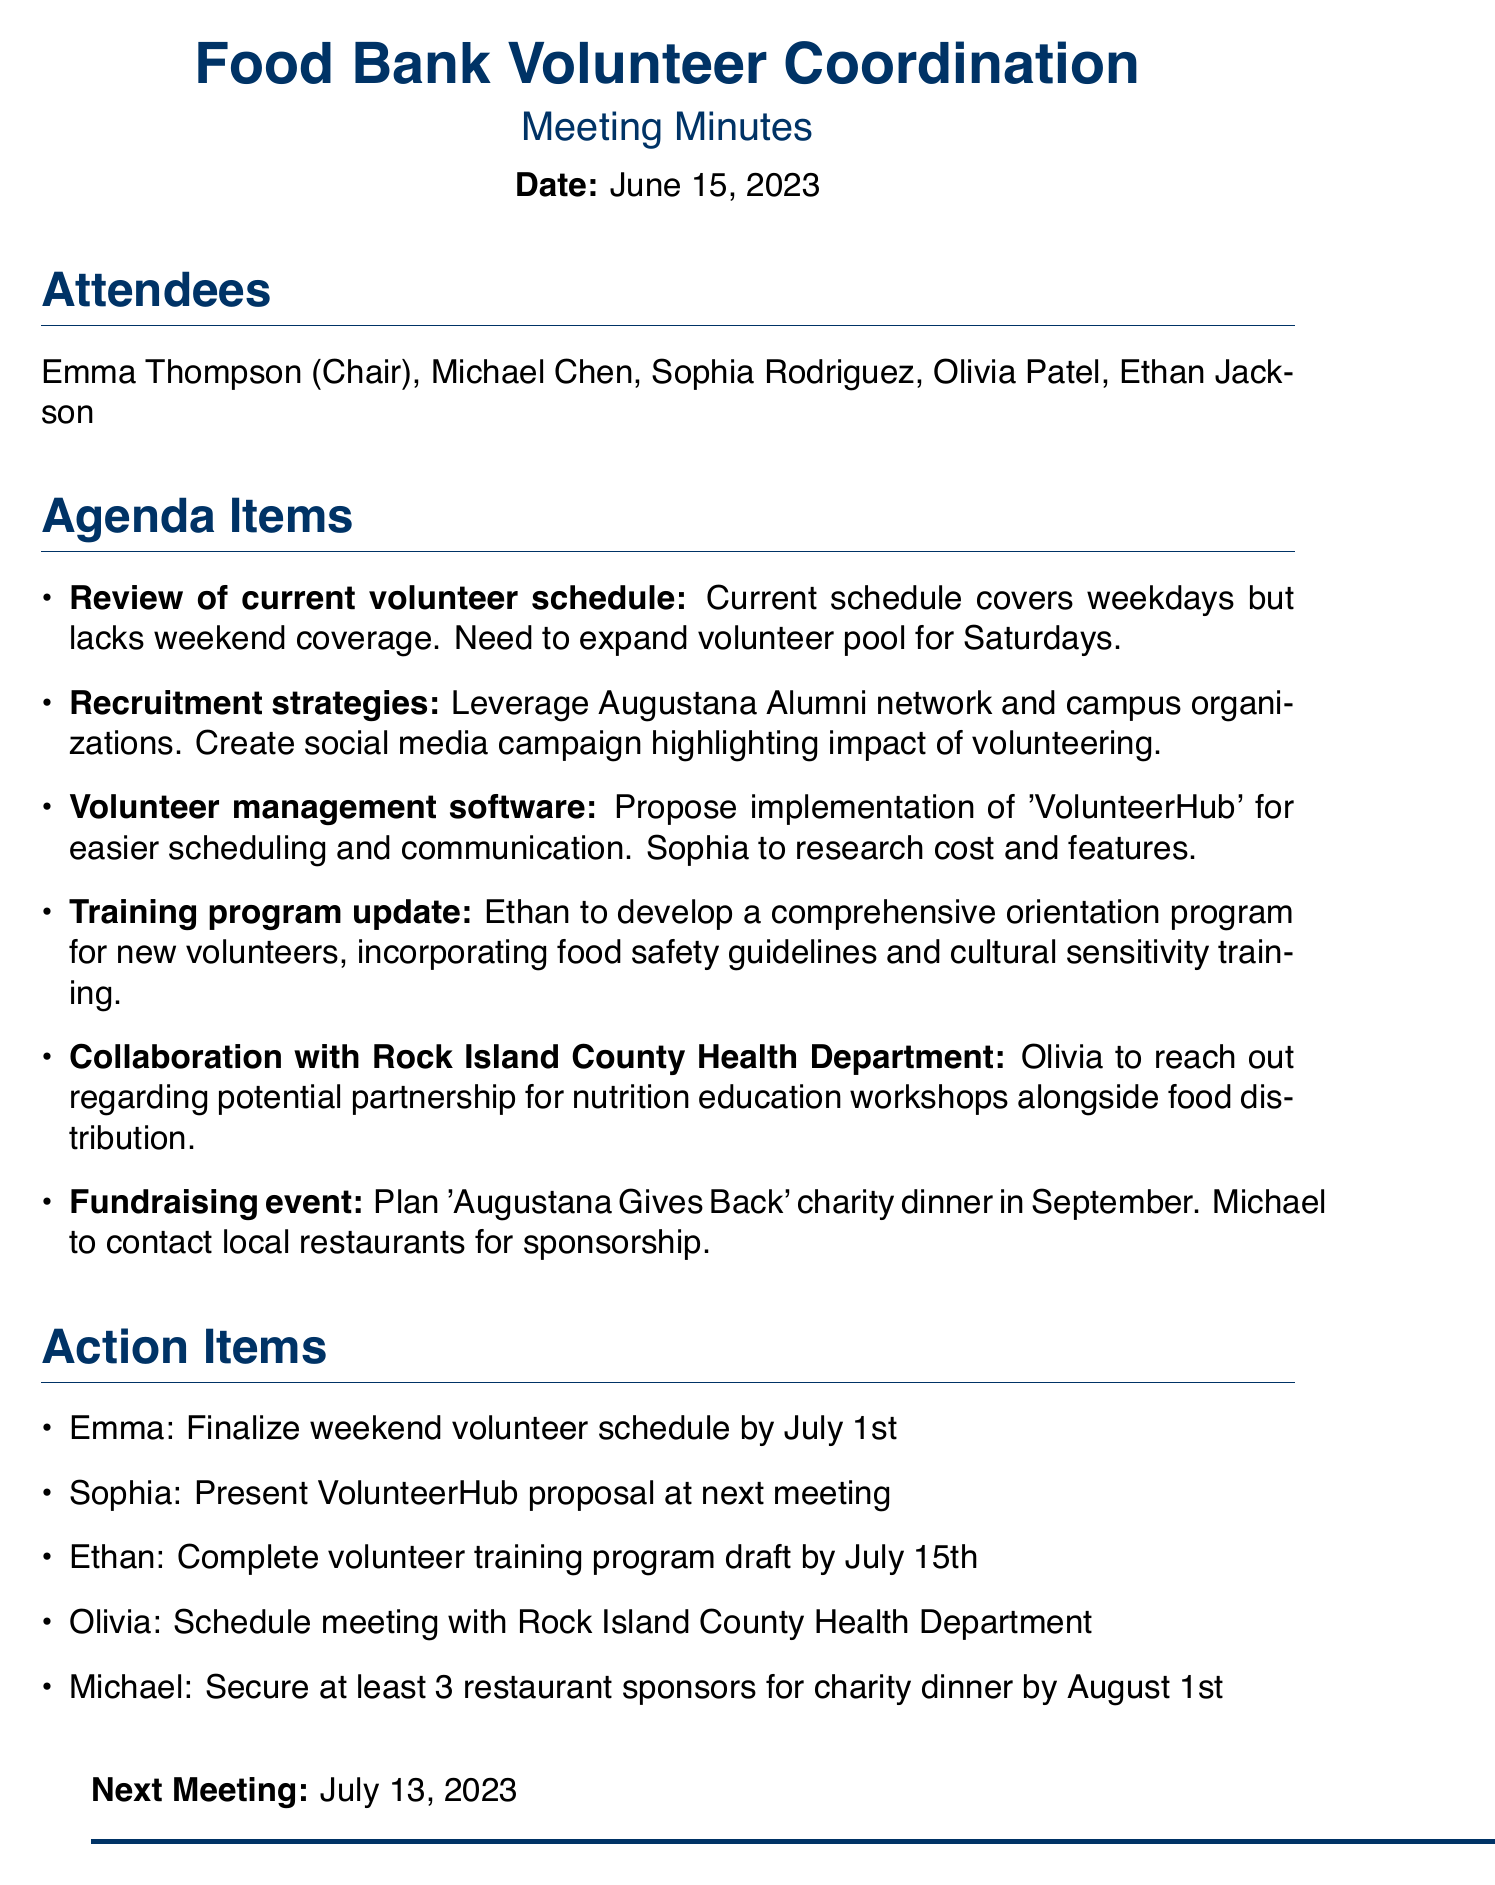What is the meeting date? The meeting date is explicitly mentioned at the beginning of the document.
Answer: June 15, 2023 Who is the Chair of the meeting? The Chair of the meeting is listed among the attendees.
Answer: Emma Thompson What software is proposed for volunteer management? The software proposal is included in the agenda items.
Answer: VolunteerHub What is the action item for Ethan? The action items include specific tasks assigned to attendees.
Answer: Complete volunteer training program draft by July 15th What event is planned for September? The agenda includes a fundraising event scheduled for September.
Answer: Augustana Gives Back charity dinner How many restaurant sponsors does Michael need to secure? The required number of sponsors is specified in the action items.
Answer: At least 3 When is the next meeting scheduled? The next meeting date is mentioned at the end of the document.
Answer: July 13, 2023 What is one recruitment strategy mentioned? Various strategies are outlined in the agenda items related to recruitment.
Answer: Leverage Augustana Alumni network What specific training will Ethan develop for new volunteers? The training program update describes a type of training to be developed.
Answer: Orientation program incorporating food safety guidelines and cultural sensitivity training 